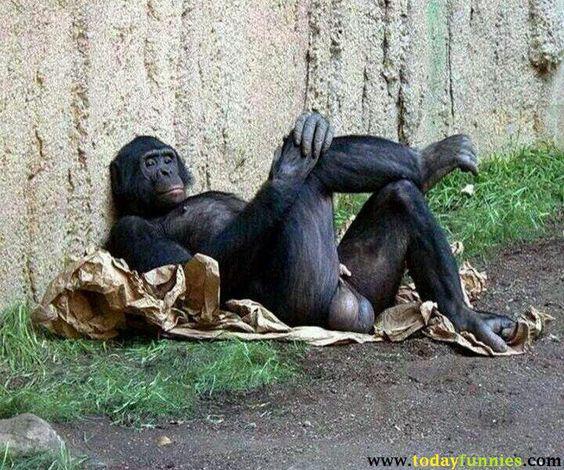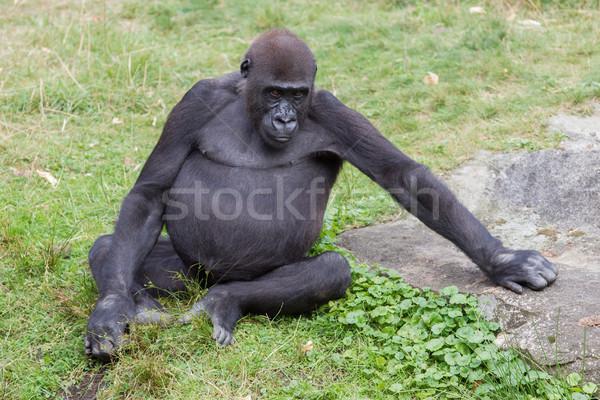The first image is the image on the left, the second image is the image on the right. Considering the images on both sides, is "One ape is laying on its stomach." valid? Answer yes or no. No. The first image is the image on the left, the second image is the image on the right. Considering the images on both sides, is "One image shows a forward-gazing gorilla reclining on its side with its head to the right, and the other image features a rightward-facing gorilla with its head in profile." valid? Answer yes or no. No. 